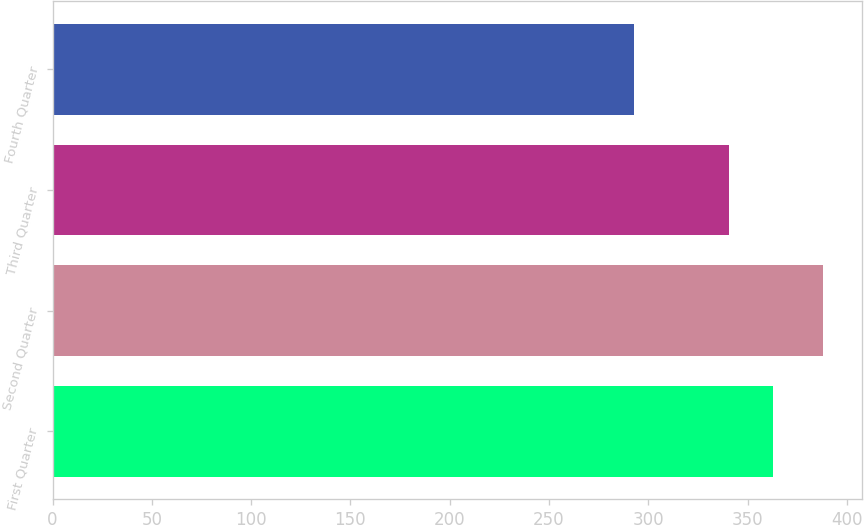Convert chart to OTSL. <chart><loc_0><loc_0><loc_500><loc_500><bar_chart><fcel>First Quarter<fcel>Second Quarter<fcel>Third Quarter<fcel>Fourth Quarter<nl><fcel>362.8<fcel>388.01<fcel>340.51<fcel>292.89<nl></chart> 